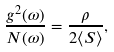<formula> <loc_0><loc_0><loc_500><loc_500>\frac { g ^ { 2 } ( \omega ) } { N ( \omega ) } = \frac { \rho } { 2 \langle S \rangle } ,</formula> 